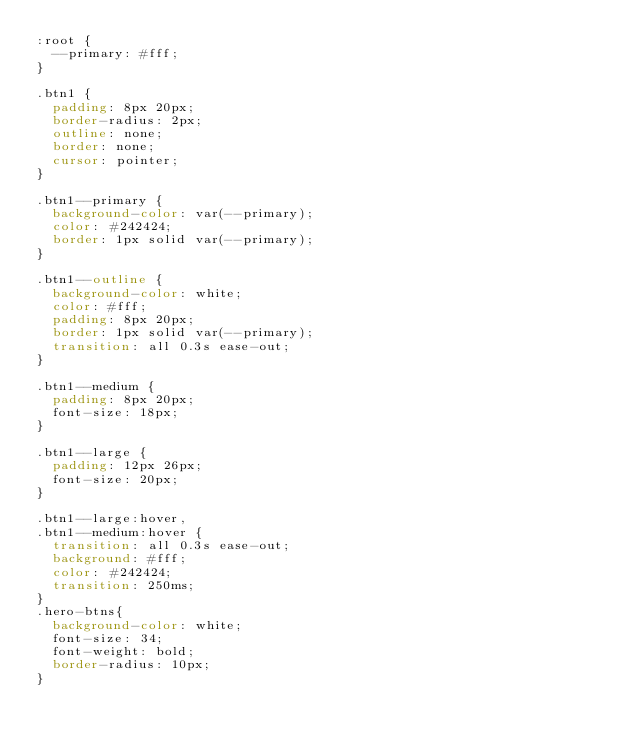Convert code to text. <code><loc_0><loc_0><loc_500><loc_500><_CSS_>:root {
  --primary: #fff;
}

.btn1 {
  padding: 8px 20px;
  border-radius: 2px;
  outline: none;
  border: none;
  cursor: pointer;
}

.btn1--primary {
  background-color: var(--primary);
  color: #242424;
  border: 1px solid var(--primary);
}

.btn1--outline {
  background-color: white;
  color: #fff;
  padding: 8px 20px;
  border: 1px solid var(--primary);
  transition: all 0.3s ease-out;
}

.btn1--medium {
  padding: 8px 20px;
  font-size: 18px;
}

.btn1--large {
  padding: 12px 26px;
  font-size: 20px;
}

.btn1--large:hover,
.btn1--medium:hover {
  transition: all 0.3s ease-out;
  background: #fff;
  color: #242424;
  transition: 250ms;
}
.hero-btns{
  background-color: white;
  font-size: 34;
  font-weight: bold;
  border-radius: 10px;
}</code> 